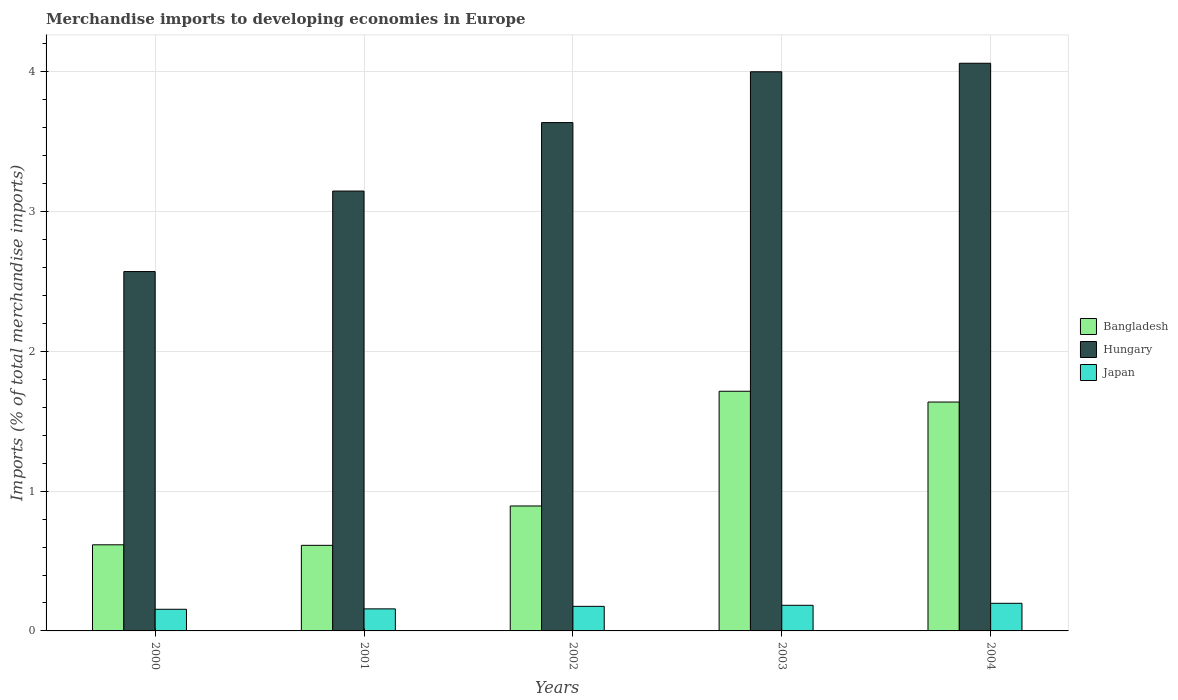How many different coloured bars are there?
Give a very brief answer. 3. How many bars are there on the 2nd tick from the left?
Provide a short and direct response. 3. How many bars are there on the 5th tick from the right?
Provide a short and direct response. 3. What is the label of the 2nd group of bars from the left?
Make the answer very short. 2001. In how many cases, is the number of bars for a given year not equal to the number of legend labels?
Your answer should be very brief. 0. What is the percentage total merchandise imports in Bangladesh in 2001?
Your answer should be very brief. 0.61. Across all years, what is the maximum percentage total merchandise imports in Japan?
Provide a short and direct response. 0.2. Across all years, what is the minimum percentage total merchandise imports in Hungary?
Your answer should be very brief. 2.57. In which year was the percentage total merchandise imports in Bangladesh maximum?
Keep it short and to the point. 2003. What is the total percentage total merchandise imports in Bangladesh in the graph?
Keep it short and to the point. 5.47. What is the difference between the percentage total merchandise imports in Bangladesh in 2001 and that in 2004?
Give a very brief answer. -1.03. What is the difference between the percentage total merchandise imports in Bangladesh in 2000 and the percentage total merchandise imports in Japan in 2002?
Keep it short and to the point. 0.44. What is the average percentage total merchandise imports in Japan per year?
Provide a short and direct response. 0.17. In the year 2002, what is the difference between the percentage total merchandise imports in Hungary and percentage total merchandise imports in Japan?
Ensure brevity in your answer.  3.46. In how many years, is the percentage total merchandise imports in Japan greater than 0.2 %?
Ensure brevity in your answer.  0. What is the ratio of the percentage total merchandise imports in Bangladesh in 2001 to that in 2004?
Offer a very short reply. 0.37. Is the difference between the percentage total merchandise imports in Hungary in 2001 and 2004 greater than the difference between the percentage total merchandise imports in Japan in 2001 and 2004?
Your answer should be compact. No. What is the difference between the highest and the second highest percentage total merchandise imports in Japan?
Your answer should be compact. 0.01. What is the difference between the highest and the lowest percentage total merchandise imports in Bangladesh?
Keep it short and to the point. 1.1. What does the 3rd bar from the left in 2001 represents?
Give a very brief answer. Japan. Are all the bars in the graph horizontal?
Your answer should be very brief. No. Where does the legend appear in the graph?
Offer a terse response. Center right. How many legend labels are there?
Ensure brevity in your answer.  3. How are the legend labels stacked?
Make the answer very short. Vertical. What is the title of the graph?
Your response must be concise. Merchandise imports to developing economies in Europe. Does "Small states" appear as one of the legend labels in the graph?
Make the answer very short. No. What is the label or title of the X-axis?
Make the answer very short. Years. What is the label or title of the Y-axis?
Offer a very short reply. Imports (% of total merchandise imports). What is the Imports (% of total merchandise imports) of Bangladesh in 2000?
Your response must be concise. 0.62. What is the Imports (% of total merchandise imports) in Hungary in 2000?
Offer a very short reply. 2.57. What is the Imports (% of total merchandise imports) in Japan in 2000?
Make the answer very short. 0.15. What is the Imports (% of total merchandise imports) of Bangladesh in 2001?
Your answer should be very brief. 0.61. What is the Imports (% of total merchandise imports) of Hungary in 2001?
Offer a very short reply. 3.15. What is the Imports (% of total merchandise imports) of Japan in 2001?
Offer a terse response. 0.16. What is the Imports (% of total merchandise imports) of Bangladesh in 2002?
Make the answer very short. 0.89. What is the Imports (% of total merchandise imports) of Hungary in 2002?
Your answer should be compact. 3.64. What is the Imports (% of total merchandise imports) in Japan in 2002?
Keep it short and to the point. 0.18. What is the Imports (% of total merchandise imports) in Bangladesh in 2003?
Offer a very short reply. 1.71. What is the Imports (% of total merchandise imports) of Hungary in 2003?
Offer a very short reply. 4. What is the Imports (% of total merchandise imports) in Japan in 2003?
Give a very brief answer. 0.18. What is the Imports (% of total merchandise imports) of Bangladesh in 2004?
Provide a succinct answer. 1.64. What is the Imports (% of total merchandise imports) of Hungary in 2004?
Your answer should be very brief. 4.06. What is the Imports (% of total merchandise imports) in Japan in 2004?
Make the answer very short. 0.2. Across all years, what is the maximum Imports (% of total merchandise imports) in Bangladesh?
Provide a short and direct response. 1.71. Across all years, what is the maximum Imports (% of total merchandise imports) in Hungary?
Give a very brief answer. 4.06. Across all years, what is the maximum Imports (% of total merchandise imports) of Japan?
Give a very brief answer. 0.2. Across all years, what is the minimum Imports (% of total merchandise imports) in Bangladesh?
Give a very brief answer. 0.61. Across all years, what is the minimum Imports (% of total merchandise imports) of Hungary?
Offer a terse response. 2.57. Across all years, what is the minimum Imports (% of total merchandise imports) of Japan?
Your response must be concise. 0.15. What is the total Imports (% of total merchandise imports) in Bangladesh in the graph?
Offer a very short reply. 5.47. What is the total Imports (% of total merchandise imports) of Hungary in the graph?
Give a very brief answer. 17.42. What is the total Imports (% of total merchandise imports) in Japan in the graph?
Offer a very short reply. 0.87. What is the difference between the Imports (% of total merchandise imports) in Bangladesh in 2000 and that in 2001?
Offer a very short reply. 0. What is the difference between the Imports (% of total merchandise imports) of Hungary in 2000 and that in 2001?
Your response must be concise. -0.58. What is the difference between the Imports (% of total merchandise imports) of Japan in 2000 and that in 2001?
Offer a terse response. -0. What is the difference between the Imports (% of total merchandise imports) of Bangladesh in 2000 and that in 2002?
Give a very brief answer. -0.28. What is the difference between the Imports (% of total merchandise imports) of Hungary in 2000 and that in 2002?
Your answer should be compact. -1.07. What is the difference between the Imports (% of total merchandise imports) in Japan in 2000 and that in 2002?
Keep it short and to the point. -0.02. What is the difference between the Imports (% of total merchandise imports) in Bangladesh in 2000 and that in 2003?
Ensure brevity in your answer.  -1.1. What is the difference between the Imports (% of total merchandise imports) in Hungary in 2000 and that in 2003?
Provide a succinct answer. -1.43. What is the difference between the Imports (% of total merchandise imports) of Japan in 2000 and that in 2003?
Make the answer very short. -0.03. What is the difference between the Imports (% of total merchandise imports) in Bangladesh in 2000 and that in 2004?
Your answer should be compact. -1.02. What is the difference between the Imports (% of total merchandise imports) of Hungary in 2000 and that in 2004?
Provide a short and direct response. -1.49. What is the difference between the Imports (% of total merchandise imports) of Japan in 2000 and that in 2004?
Keep it short and to the point. -0.04. What is the difference between the Imports (% of total merchandise imports) of Bangladesh in 2001 and that in 2002?
Give a very brief answer. -0.28. What is the difference between the Imports (% of total merchandise imports) of Hungary in 2001 and that in 2002?
Make the answer very short. -0.49. What is the difference between the Imports (% of total merchandise imports) in Japan in 2001 and that in 2002?
Offer a terse response. -0.02. What is the difference between the Imports (% of total merchandise imports) of Bangladesh in 2001 and that in 2003?
Make the answer very short. -1.1. What is the difference between the Imports (% of total merchandise imports) in Hungary in 2001 and that in 2003?
Provide a succinct answer. -0.85. What is the difference between the Imports (% of total merchandise imports) of Japan in 2001 and that in 2003?
Your answer should be very brief. -0.03. What is the difference between the Imports (% of total merchandise imports) of Bangladesh in 2001 and that in 2004?
Provide a short and direct response. -1.03. What is the difference between the Imports (% of total merchandise imports) in Hungary in 2001 and that in 2004?
Make the answer very short. -0.91. What is the difference between the Imports (% of total merchandise imports) of Japan in 2001 and that in 2004?
Ensure brevity in your answer.  -0.04. What is the difference between the Imports (% of total merchandise imports) in Bangladesh in 2002 and that in 2003?
Offer a terse response. -0.82. What is the difference between the Imports (% of total merchandise imports) in Hungary in 2002 and that in 2003?
Offer a terse response. -0.36. What is the difference between the Imports (% of total merchandise imports) of Japan in 2002 and that in 2003?
Make the answer very short. -0.01. What is the difference between the Imports (% of total merchandise imports) in Bangladesh in 2002 and that in 2004?
Ensure brevity in your answer.  -0.74. What is the difference between the Imports (% of total merchandise imports) of Hungary in 2002 and that in 2004?
Give a very brief answer. -0.42. What is the difference between the Imports (% of total merchandise imports) in Japan in 2002 and that in 2004?
Make the answer very short. -0.02. What is the difference between the Imports (% of total merchandise imports) of Bangladesh in 2003 and that in 2004?
Keep it short and to the point. 0.08. What is the difference between the Imports (% of total merchandise imports) of Hungary in 2003 and that in 2004?
Your response must be concise. -0.06. What is the difference between the Imports (% of total merchandise imports) in Japan in 2003 and that in 2004?
Your response must be concise. -0.01. What is the difference between the Imports (% of total merchandise imports) of Bangladesh in 2000 and the Imports (% of total merchandise imports) of Hungary in 2001?
Make the answer very short. -2.53. What is the difference between the Imports (% of total merchandise imports) of Bangladesh in 2000 and the Imports (% of total merchandise imports) of Japan in 2001?
Offer a terse response. 0.46. What is the difference between the Imports (% of total merchandise imports) of Hungary in 2000 and the Imports (% of total merchandise imports) of Japan in 2001?
Provide a succinct answer. 2.41. What is the difference between the Imports (% of total merchandise imports) in Bangladesh in 2000 and the Imports (% of total merchandise imports) in Hungary in 2002?
Provide a succinct answer. -3.02. What is the difference between the Imports (% of total merchandise imports) of Bangladesh in 2000 and the Imports (% of total merchandise imports) of Japan in 2002?
Offer a very short reply. 0.44. What is the difference between the Imports (% of total merchandise imports) of Hungary in 2000 and the Imports (% of total merchandise imports) of Japan in 2002?
Your answer should be compact. 2.4. What is the difference between the Imports (% of total merchandise imports) of Bangladesh in 2000 and the Imports (% of total merchandise imports) of Hungary in 2003?
Your answer should be very brief. -3.38. What is the difference between the Imports (% of total merchandise imports) of Bangladesh in 2000 and the Imports (% of total merchandise imports) of Japan in 2003?
Keep it short and to the point. 0.43. What is the difference between the Imports (% of total merchandise imports) in Hungary in 2000 and the Imports (% of total merchandise imports) in Japan in 2003?
Provide a succinct answer. 2.39. What is the difference between the Imports (% of total merchandise imports) in Bangladesh in 2000 and the Imports (% of total merchandise imports) in Hungary in 2004?
Your answer should be compact. -3.44. What is the difference between the Imports (% of total merchandise imports) of Bangladesh in 2000 and the Imports (% of total merchandise imports) of Japan in 2004?
Make the answer very short. 0.42. What is the difference between the Imports (% of total merchandise imports) in Hungary in 2000 and the Imports (% of total merchandise imports) in Japan in 2004?
Ensure brevity in your answer.  2.37. What is the difference between the Imports (% of total merchandise imports) in Bangladesh in 2001 and the Imports (% of total merchandise imports) in Hungary in 2002?
Your answer should be very brief. -3.02. What is the difference between the Imports (% of total merchandise imports) in Bangladesh in 2001 and the Imports (% of total merchandise imports) in Japan in 2002?
Your response must be concise. 0.44. What is the difference between the Imports (% of total merchandise imports) in Hungary in 2001 and the Imports (% of total merchandise imports) in Japan in 2002?
Provide a succinct answer. 2.97. What is the difference between the Imports (% of total merchandise imports) in Bangladesh in 2001 and the Imports (% of total merchandise imports) in Hungary in 2003?
Offer a terse response. -3.39. What is the difference between the Imports (% of total merchandise imports) of Bangladesh in 2001 and the Imports (% of total merchandise imports) of Japan in 2003?
Provide a short and direct response. 0.43. What is the difference between the Imports (% of total merchandise imports) of Hungary in 2001 and the Imports (% of total merchandise imports) of Japan in 2003?
Your answer should be compact. 2.96. What is the difference between the Imports (% of total merchandise imports) of Bangladesh in 2001 and the Imports (% of total merchandise imports) of Hungary in 2004?
Offer a terse response. -3.45. What is the difference between the Imports (% of total merchandise imports) of Bangladesh in 2001 and the Imports (% of total merchandise imports) of Japan in 2004?
Offer a very short reply. 0.41. What is the difference between the Imports (% of total merchandise imports) of Hungary in 2001 and the Imports (% of total merchandise imports) of Japan in 2004?
Give a very brief answer. 2.95. What is the difference between the Imports (% of total merchandise imports) in Bangladesh in 2002 and the Imports (% of total merchandise imports) in Hungary in 2003?
Ensure brevity in your answer.  -3.11. What is the difference between the Imports (% of total merchandise imports) of Bangladesh in 2002 and the Imports (% of total merchandise imports) of Japan in 2003?
Make the answer very short. 0.71. What is the difference between the Imports (% of total merchandise imports) in Hungary in 2002 and the Imports (% of total merchandise imports) in Japan in 2003?
Offer a very short reply. 3.45. What is the difference between the Imports (% of total merchandise imports) of Bangladesh in 2002 and the Imports (% of total merchandise imports) of Hungary in 2004?
Provide a short and direct response. -3.17. What is the difference between the Imports (% of total merchandise imports) of Bangladesh in 2002 and the Imports (% of total merchandise imports) of Japan in 2004?
Offer a terse response. 0.7. What is the difference between the Imports (% of total merchandise imports) in Hungary in 2002 and the Imports (% of total merchandise imports) in Japan in 2004?
Ensure brevity in your answer.  3.44. What is the difference between the Imports (% of total merchandise imports) of Bangladesh in 2003 and the Imports (% of total merchandise imports) of Hungary in 2004?
Offer a terse response. -2.35. What is the difference between the Imports (% of total merchandise imports) of Bangladesh in 2003 and the Imports (% of total merchandise imports) of Japan in 2004?
Offer a very short reply. 1.52. What is the difference between the Imports (% of total merchandise imports) of Hungary in 2003 and the Imports (% of total merchandise imports) of Japan in 2004?
Your answer should be very brief. 3.8. What is the average Imports (% of total merchandise imports) in Bangladesh per year?
Your response must be concise. 1.09. What is the average Imports (% of total merchandise imports) in Hungary per year?
Offer a very short reply. 3.48. What is the average Imports (% of total merchandise imports) of Japan per year?
Provide a succinct answer. 0.17. In the year 2000, what is the difference between the Imports (% of total merchandise imports) in Bangladesh and Imports (% of total merchandise imports) in Hungary?
Your answer should be compact. -1.95. In the year 2000, what is the difference between the Imports (% of total merchandise imports) in Bangladesh and Imports (% of total merchandise imports) in Japan?
Offer a very short reply. 0.46. In the year 2000, what is the difference between the Imports (% of total merchandise imports) in Hungary and Imports (% of total merchandise imports) in Japan?
Keep it short and to the point. 2.42. In the year 2001, what is the difference between the Imports (% of total merchandise imports) in Bangladesh and Imports (% of total merchandise imports) in Hungary?
Your answer should be compact. -2.53. In the year 2001, what is the difference between the Imports (% of total merchandise imports) in Bangladesh and Imports (% of total merchandise imports) in Japan?
Provide a succinct answer. 0.45. In the year 2001, what is the difference between the Imports (% of total merchandise imports) of Hungary and Imports (% of total merchandise imports) of Japan?
Your response must be concise. 2.99. In the year 2002, what is the difference between the Imports (% of total merchandise imports) of Bangladesh and Imports (% of total merchandise imports) of Hungary?
Offer a terse response. -2.74. In the year 2002, what is the difference between the Imports (% of total merchandise imports) of Bangladesh and Imports (% of total merchandise imports) of Japan?
Offer a terse response. 0.72. In the year 2002, what is the difference between the Imports (% of total merchandise imports) of Hungary and Imports (% of total merchandise imports) of Japan?
Offer a very short reply. 3.46. In the year 2003, what is the difference between the Imports (% of total merchandise imports) of Bangladesh and Imports (% of total merchandise imports) of Hungary?
Offer a very short reply. -2.29. In the year 2003, what is the difference between the Imports (% of total merchandise imports) in Bangladesh and Imports (% of total merchandise imports) in Japan?
Provide a short and direct response. 1.53. In the year 2003, what is the difference between the Imports (% of total merchandise imports) in Hungary and Imports (% of total merchandise imports) in Japan?
Offer a terse response. 3.82. In the year 2004, what is the difference between the Imports (% of total merchandise imports) of Bangladesh and Imports (% of total merchandise imports) of Hungary?
Keep it short and to the point. -2.42. In the year 2004, what is the difference between the Imports (% of total merchandise imports) of Bangladesh and Imports (% of total merchandise imports) of Japan?
Ensure brevity in your answer.  1.44. In the year 2004, what is the difference between the Imports (% of total merchandise imports) in Hungary and Imports (% of total merchandise imports) in Japan?
Provide a short and direct response. 3.86. What is the ratio of the Imports (% of total merchandise imports) of Bangladesh in 2000 to that in 2001?
Provide a succinct answer. 1.01. What is the ratio of the Imports (% of total merchandise imports) of Hungary in 2000 to that in 2001?
Your response must be concise. 0.82. What is the ratio of the Imports (% of total merchandise imports) of Japan in 2000 to that in 2001?
Offer a terse response. 0.98. What is the ratio of the Imports (% of total merchandise imports) of Bangladesh in 2000 to that in 2002?
Ensure brevity in your answer.  0.69. What is the ratio of the Imports (% of total merchandise imports) in Hungary in 2000 to that in 2002?
Your response must be concise. 0.71. What is the ratio of the Imports (% of total merchandise imports) in Japan in 2000 to that in 2002?
Offer a very short reply. 0.88. What is the ratio of the Imports (% of total merchandise imports) in Bangladesh in 2000 to that in 2003?
Offer a very short reply. 0.36. What is the ratio of the Imports (% of total merchandise imports) in Hungary in 2000 to that in 2003?
Your answer should be compact. 0.64. What is the ratio of the Imports (% of total merchandise imports) in Japan in 2000 to that in 2003?
Keep it short and to the point. 0.85. What is the ratio of the Imports (% of total merchandise imports) in Bangladesh in 2000 to that in 2004?
Offer a terse response. 0.38. What is the ratio of the Imports (% of total merchandise imports) in Hungary in 2000 to that in 2004?
Make the answer very short. 0.63. What is the ratio of the Imports (% of total merchandise imports) in Japan in 2000 to that in 2004?
Your answer should be very brief. 0.78. What is the ratio of the Imports (% of total merchandise imports) of Bangladesh in 2001 to that in 2002?
Your answer should be very brief. 0.68. What is the ratio of the Imports (% of total merchandise imports) of Hungary in 2001 to that in 2002?
Keep it short and to the point. 0.87. What is the ratio of the Imports (% of total merchandise imports) of Japan in 2001 to that in 2002?
Provide a short and direct response. 0.9. What is the ratio of the Imports (% of total merchandise imports) in Bangladesh in 2001 to that in 2003?
Your answer should be compact. 0.36. What is the ratio of the Imports (% of total merchandise imports) of Hungary in 2001 to that in 2003?
Give a very brief answer. 0.79. What is the ratio of the Imports (% of total merchandise imports) of Japan in 2001 to that in 2003?
Your response must be concise. 0.86. What is the ratio of the Imports (% of total merchandise imports) in Bangladesh in 2001 to that in 2004?
Make the answer very short. 0.37. What is the ratio of the Imports (% of total merchandise imports) of Hungary in 2001 to that in 2004?
Give a very brief answer. 0.77. What is the ratio of the Imports (% of total merchandise imports) of Japan in 2001 to that in 2004?
Make the answer very short. 0.8. What is the ratio of the Imports (% of total merchandise imports) in Bangladesh in 2002 to that in 2003?
Your response must be concise. 0.52. What is the ratio of the Imports (% of total merchandise imports) in Hungary in 2002 to that in 2003?
Your answer should be compact. 0.91. What is the ratio of the Imports (% of total merchandise imports) of Japan in 2002 to that in 2003?
Provide a short and direct response. 0.96. What is the ratio of the Imports (% of total merchandise imports) of Bangladesh in 2002 to that in 2004?
Your answer should be very brief. 0.55. What is the ratio of the Imports (% of total merchandise imports) of Hungary in 2002 to that in 2004?
Provide a short and direct response. 0.9. What is the ratio of the Imports (% of total merchandise imports) of Japan in 2002 to that in 2004?
Make the answer very short. 0.89. What is the ratio of the Imports (% of total merchandise imports) of Bangladesh in 2003 to that in 2004?
Your answer should be very brief. 1.05. What is the ratio of the Imports (% of total merchandise imports) of Hungary in 2003 to that in 2004?
Provide a succinct answer. 0.98. What is the ratio of the Imports (% of total merchandise imports) in Japan in 2003 to that in 2004?
Offer a terse response. 0.93. What is the difference between the highest and the second highest Imports (% of total merchandise imports) of Bangladesh?
Give a very brief answer. 0.08. What is the difference between the highest and the second highest Imports (% of total merchandise imports) of Hungary?
Give a very brief answer. 0.06. What is the difference between the highest and the second highest Imports (% of total merchandise imports) in Japan?
Your answer should be very brief. 0.01. What is the difference between the highest and the lowest Imports (% of total merchandise imports) in Bangladesh?
Ensure brevity in your answer.  1.1. What is the difference between the highest and the lowest Imports (% of total merchandise imports) of Hungary?
Your answer should be very brief. 1.49. What is the difference between the highest and the lowest Imports (% of total merchandise imports) in Japan?
Your answer should be compact. 0.04. 